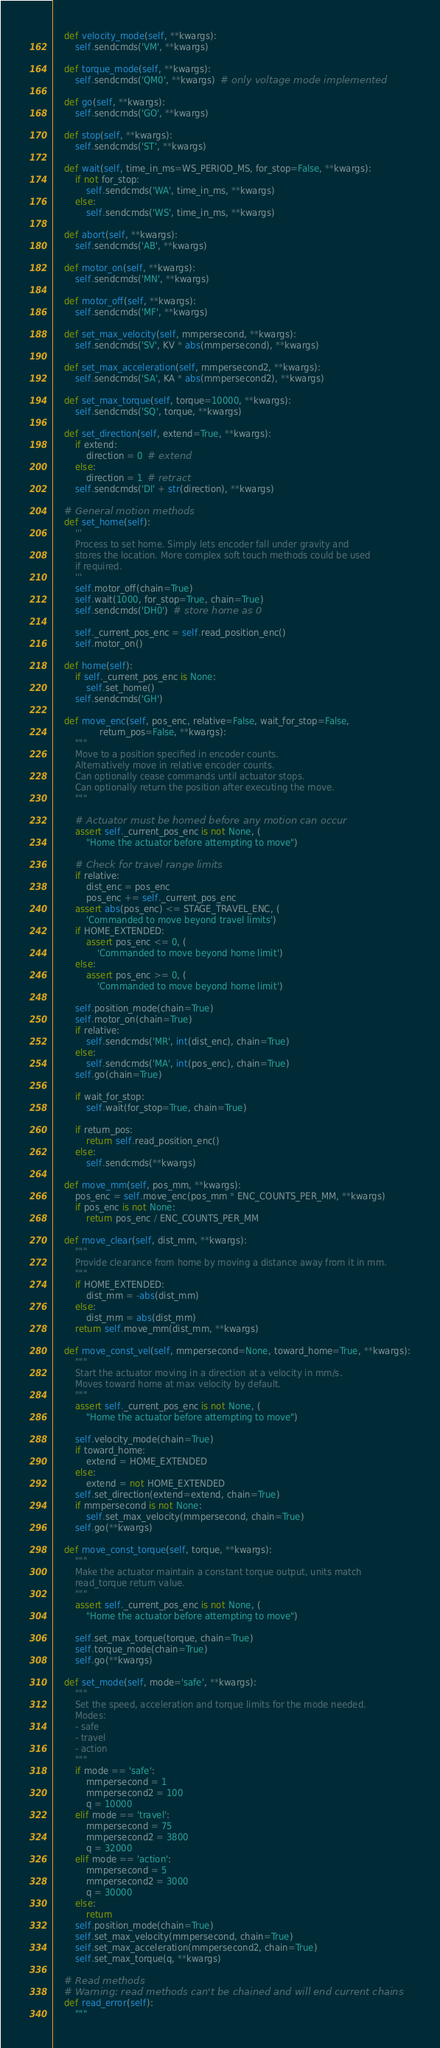Convert code to text. <code><loc_0><loc_0><loc_500><loc_500><_Python_>
    def velocity_mode(self, **kwargs):
        self.sendcmds('VM', **kwargs)

    def torque_mode(self, **kwargs):
        self.sendcmds('QM0', **kwargs)  # only voltage mode implemented

    def go(self, **kwargs):
        self.sendcmds('GO', **kwargs)

    def stop(self, **kwargs):
        self.sendcmds('ST', **kwargs)

    def wait(self, time_in_ms=WS_PERIOD_MS, for_stop=False, **kwargs):
        if not for_stop:
            self.sendcmds('WA', time_in_ms, **kwargs)
        else:
            self.sendcmds('WS', time_in_ms, **kwargs)

    def abort(self, **kwargs):
        self.sendcmds('AB', **kwargs)

    def motor_on(self, **kwargs):
        self.sendcmds('MN', **kwargs)

    def motor_off(self, **kwargs):
        self.sendcmds('MF', **kwargs)

    def set_max_velocity(self, mmpersecond, **kwargs):
        self.sendcmds('SV', KV * abs(mmpersecond), **kwargs)

    def set_max_acceleration(self, mmpersecond2, **kwargs):
        self.sendcmds('SA', KA * abs(mmpersecond2), **kwargs)

    def set_max_torque(self, torque=10000, **kwargs):
        self.sendcmds('SQ', torque, **kwargs)

    def set_direction(self, extend=True, **kwargs):
        if extend:
            direction = 0  # extend
        else:
            direction = 1  # retract
        self.sendcmds('DI' + str(direction), **kwargs)

    # General motion methods
    def set_home(self):
        '''
        Process to set home. Simply lets encoder fall under gravity and
        stores the location. More complex soft touch methods could be used
        if required.
        '''
        self.motor_off(chain=True)
        self.wait(1000, for_stop=True, chain=True)
        self.sendcmds('DH0')  # store home as 0

        self._current_pos_enc = self.read_position_enc()
        self.motor_on()

    def home(self):
        if self._current_pos_enc is None:
            self.set_home()
        self.sendcmds('GH')

    def move_enc(self, pos_enc, relative=False, wait_for_stop=False,
                 return_pos=False, **kwargs):
        """
        Move to a position specified in encoder counts.
        Alternatively move in relative encoder counts.
        Can optionally cease commands until actuator stops.
        Can optionally return the position after executing the move.
        """

        # Actuator must be homed before any motion can occur
        assert self._current_pos_enc is not None, (
            "Home the actuator before attempting to move")

        # Check for travel range limits
        if relative:
            dist_enc = pos_enc
            pos_enc += self._current_pos_enc
        assert abs(pos_enc) <= STAGE_TRAVEL_ENC, (
            'Commanded to move beyond travel limits')
        if HOME_EXTENDED:
            assert pos_enc <= 0, (
                'Commanded to move beyond home limit')
        else:
            assert pos_enc >= 0, (
                'Commanded to move beyond home limit')

        self.position_mode(chain=True)
        self.motor_on(chain=True)
        if relative:
            self.sendcmds('MR', int(dist_enc), chain=True)
        else:
            self.sendcmds('MA', int(pos_enc), chain=True)
        self.go(chain=True)

        if wait_for_stop:
            self.wait(for_stop=True, chain=True)

        if return_pos:
            return self.read_position_enc()
        else:
            self.sendcmds(**kwargs)

    def move_mm(self, pos_mm, **kwargs):
        pos_enc = self.move_enc(pos_mm * ENC_COUNTS_PER_MM, **kwargs)
        if pos_enc is not None:
            return pos_enc / ENC_COUNTS_PER_MM

    def move_clear(self, dist_mm, **kwargs):
        """
        Provide clearance from home by moving a distance away from it in mm.
        """
        if HOME_EXTENDED:
            dist_mm = -abs(dist_mm)
        else:
            dist_mm = abs(dist_mm)
        return self.move_mm(dist_mm, **kwargs)

    def move_const_vel(self, mmpersecond=None, toward_home=True, **kwargs):
        """
        Start the actuator moving in a direction at a velocity in mm/s.
        Moves toward home at max velocity by default.
        """
        assert self._current_pos_enc is not None, (
            "Home the actuator before attempting to move")

        self.velocity_mode(chain=True)
        if toward_home:
            extend = HOME_EXTENDED
        else:
            extend = not HOME_EXTENDED
        self.set_direction(extend=extend, chain=True)
        if mmpersecond is not None:
            self.set_max_velocity(mmpersecond, chain=True)
        self.go(**kwargs)

    def move_const_torque(self, torque, **kwargs):
        """
        Make the actuator maintain a constant torque output, units match
        read_torque return value.
        """
        assert self._current_pos_enc is not None, (
            "Home the actuator before attempting to move")

        self.set_max_torque(torque, chain=True)
        self.torque_mode(chain=True)
        self.go(**kwargs)

    def set_mode(self, mode='safe', **kwargs):
        """
        Set the speed, acceleration and torque limits for the mode needed.
        Modes:
        - safe
        - travel
        - action
        """
        if mode == 'safe':
            mmpersecond = 1
            mmpersecond2 = 100
            q = 10000
        elif mode == 'travel':
            mmpersecond = 75
            mmpersecond2 = 3800
            q = 32000
        elif mode == 'action':
            mmpersecond = 5
            mmpersecond2 = 3000
            q = 30000
        else:
            return
        self.position_mode(chain=True)
        self.set_max_velocity(mmpersecond, chain=True)
        self.set_max_acceleration(mmpersecond2, chain=True)
        self.set_max_torque(q, **kwargs)

    # Read methods
    # Warning: read methods can't be chained and will end current chains
    def read_error(self):
        """</code> 